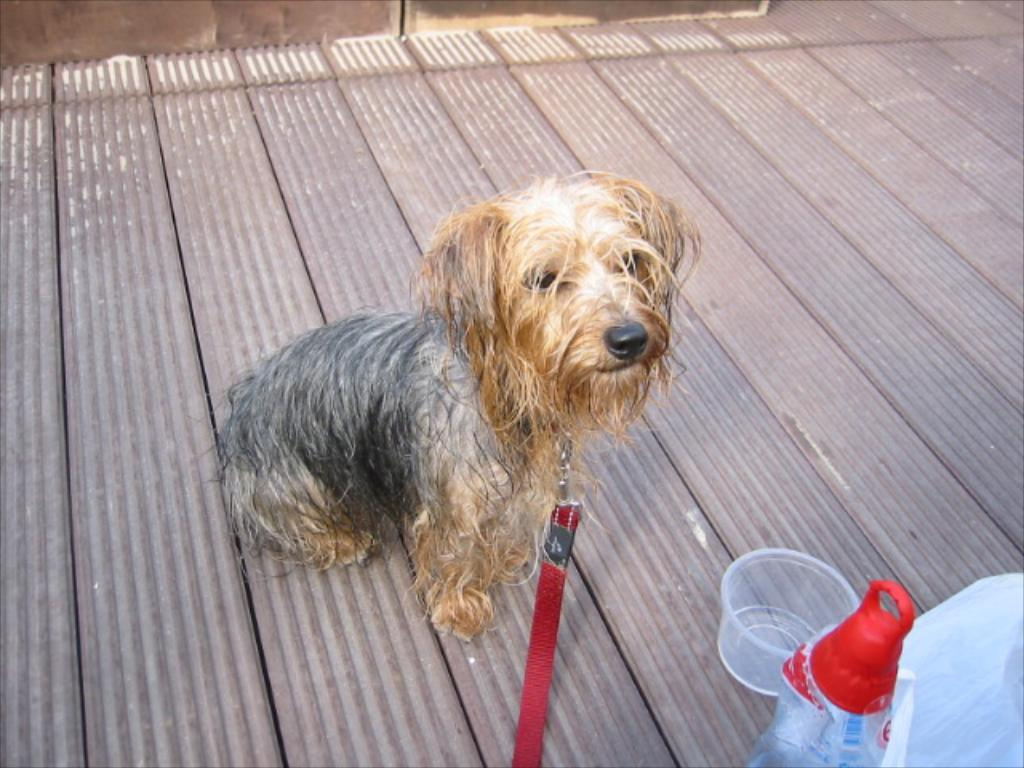What is the main subject in the center of the image? There is a dog in the center of the image. What other objects can be seen in the image? There is a cup and a bottle in the image. Is there any object that might be used to cover something in the image? Yes, there is a cover in the image. Can you see a river flowing in the background of the image? There is no river visible in the image. Is there any magic happening in the image? There is no indication of any magic happening in the image. 